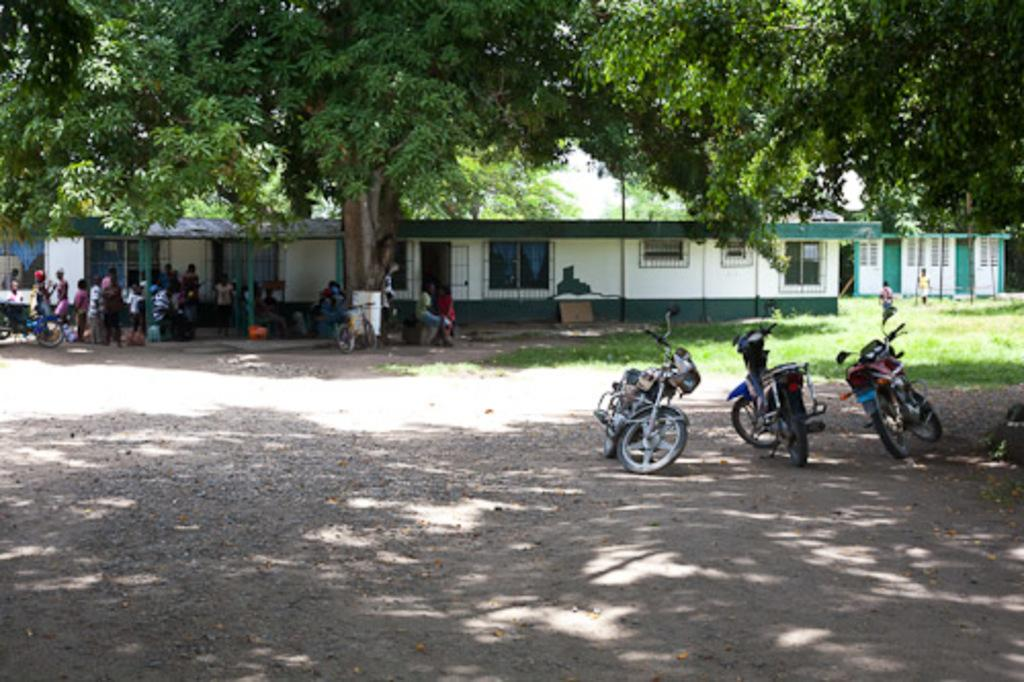What can be seen on the road in the image? There are vehicles on the road in the image. What type of structure is visible in the image? There is a building visible in the image. What is a notable feature of the building? The building has glass windows. What type of vegetation is present in the image? There are trees in the image. Who or what else can be seen in the image? There are people visible in the image. What colors are used for the building in the image? The building is in white and green color. What type of mark is visible on the birthday cake in the image? There is no birthday cake present in the image. What form does the building take in the image? The building is a rectangular structure with glass windows, but it does not have a specific form beyond that. 